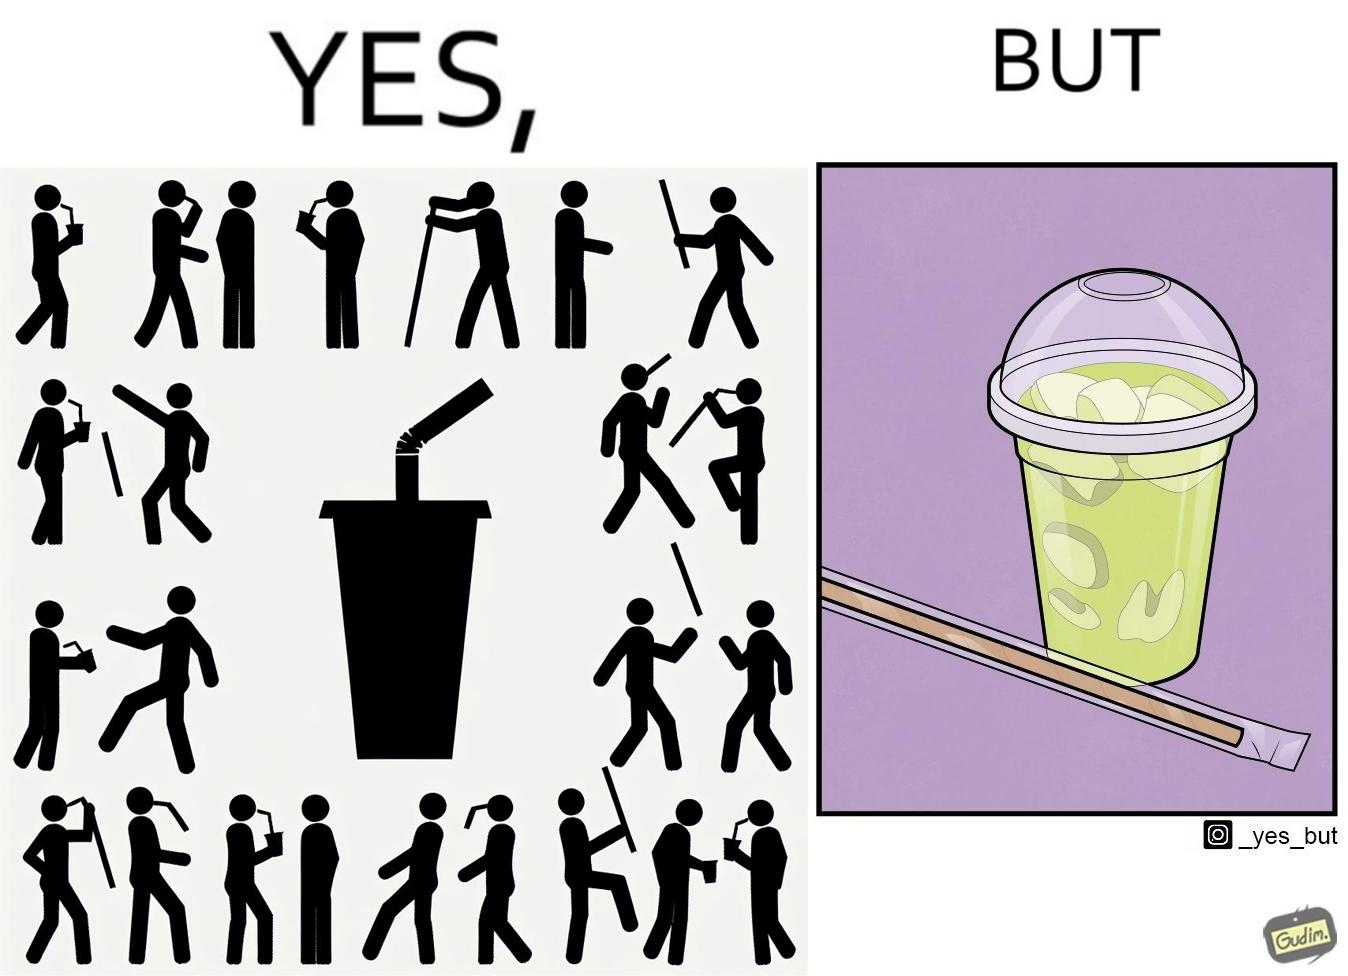Describe the content of this image. The images are ironic since paper straws were invented to reduce use of plastic in the form of plastic straws. However, these straws come in plastic packages and are served with plastic cups, defeating  the purpose 